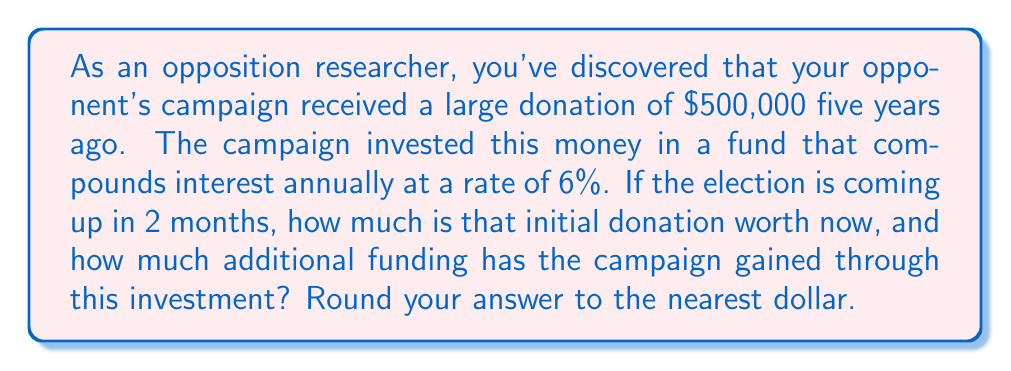Help me with this question. To solve this problem, we'll use the compound interest formula:

$$A = P(1 + r)^t$$

Where:
$A$ = Final amount
$P$ = Principal (initial investment)
$r$ = Annual interest rate (as a decimal)
$t$ = Time in years

Given:
$P = \$500,000$
$r = 0.06$ (6% expressed as a decimal)
$t = 5$ years

Let's calculate:

$$A = 500,000(1 + 0.06)^5$$
$$A = 500,000(1.06)^5$$
$$A = 500,000(1.3382256)$$
$$A = 669,112.80$$

Rounding to the nearest dollar: $A = \$669,113$

To find the additional funding gained:

$$\text{Additional Funding} = \text{Final Amount} - \text{Initial Investment}$$
$$\text{Additional Funding} = \$669,113 - \$500,000 = \$169,113$$
Answer: The initial donation is now worth $669,113, and the campaign has gained an additional $169,113 through this investment. 